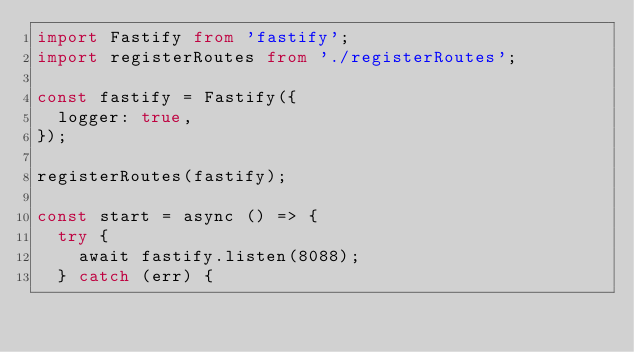<code> <loc_0><loc_0><loc_500><loc_500><_TypeScript_>import Fastify from 'fastify';
import registerRoutes from './registerRoutes';

const fastify = Fastify({
  logger: true,
});

registerRoutes(fastify);

const start = async () => {
  try {
    await fastify.listen(8088);
  } catch (err) {</code> 